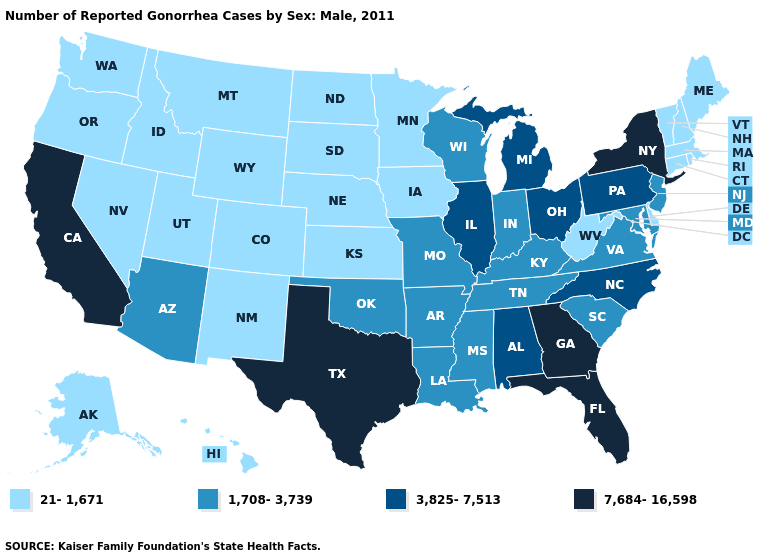What is the highest value in states that border Georgia?
Quick response, please. 7,684-16,598. What is the lowest value in states that border Missouri?
Concise answer only. 21-1,671. Which states have the lowest value in the USA?
Answer briefly. Alaska, Colorado, Connecticut, Delaware, Hawaii, Idaho, Iowa, Kansas, Maine, Massachusetts, Minnesota, Montana, Nebraska, Nevada, New Hampshire, New Mexico, North Dakota, Oregon, Rhode Island, South Dakota, Utah, Vermont, Washington, West Virginia, Wyoming. What is the value of South Dakota?
Keep it brief. 21-1,671. What is the lowest value in states that border Connecticut?
Short answer required. 21-1,671. How many symbols are there in the legend?
Give a very brief answer. 4. What is the highest value in the Northeast ?
Write a very short answer. 7,684-16,598. What is the value of Utah?
Concise answer only. 21-1,671. Which states have the lowest value in the USA?
Answer briefly. Alaska, Colorado, Connecticut, Delaware, Hawaii, Idaho, Iowa, Kansas, Maine, Massachusetts, Minnesota, Montana, Nebraska, Nevada, New Hampshire, New Mexico, North Dakota, Oregon, Rhode Island, South Dakota, Utah, Vermont, Washington, West Virginia, Wyoming. Does Illinois have the lowest value in the USA?
Keep it brief. No. What is the value of Oregon?
Give a very brief answer. 21-1,671. Name the states that have a value in the range 1,708-3,739?
Keep it brief. Arizona, Arkansas, Indiana, Kentucky, Louisiana, Maryland, Mississippi, Missouri, New Jersey, Oklahoma, South Carolina, Tennessee, Virginia, Wisconsin. Name the states that have a value in the range 7,684-16,598?
Answer briefly. California, Florida, Georgia, New York, Texas. What is the lowest value in the West?
Be succinct. 21-1,671. What is the value of Maine?
Short answer required. 21-1,671. 